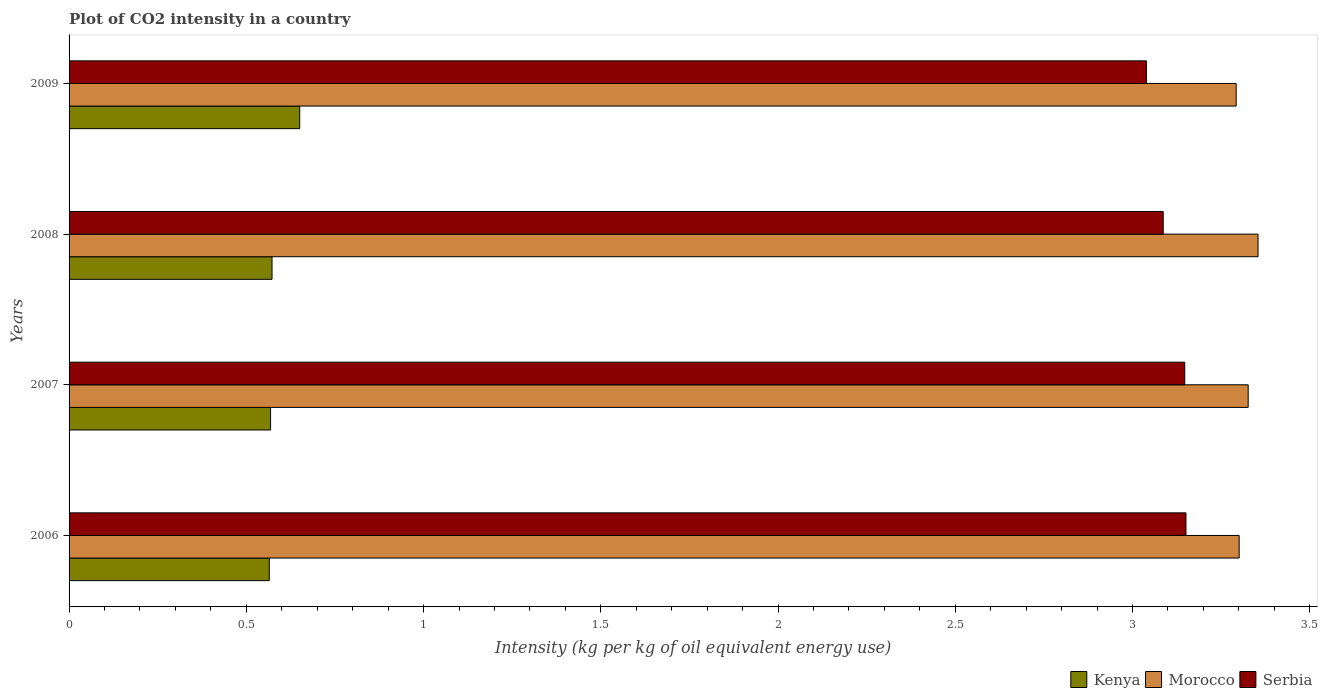How many different coloured bars are there?
Offer a very short reply. 3. Are the number of bars on each tick of the Y-axis equal?
Keep it short and to the point. Yes. What is the label of the 2nd group of bars from the top?
Provide a short and direct response. 2008. What is the CO2 intensity in in Morocco in 2007?
Make the answer very short. 3.33. Across all years, what is the maximum CO2 intensity in in Serbia?
Offer a terse response. 3.15. Across all years, what is the minimum CO2 intensity in in Serbia?
Offer a very short reply. 3.04. In which year was the CO2 intensity in in Morocco maximum?
Give a very brief answer. 2008. What is the total CO2 intensity in in Kenya in the graph?
Give a very brief answer. 2.36. What is the difference between the CO2 intensity in in Morocco in 2006 and that in 2007?
Your answer should be very brief. -0.03. What is the difference between the CO2 intensity in in Kenya in 2006 and the CO2 intensity in in Serbia in 2009?
Keep it short and to the point. -2.47. What is the average CO2 intensity in in Kenya per year?
Keep it short and to the point. 0.59. In the year 2008, what is the difference between the CO2 intensity in in Kenya and CO2 intensity in in Serbia?
Keep it short and to the point. -2.51. In how many years, is the CO2 intensity in in Kenya greater than 1.9 kg?
Provide a short and direct response. 0. What is the ratio of the CO2 intensity in in Morocco in 2007 to that in 2008?
Provide a succinct answer. 0.99. Is the CO2 intensity in in Kenya in 2007 less than that in 2009?
Make the answer very short. Yes. Is the difference between the CO2 intensity in in Kenya in 2006 and 2008 greater than the difference between the CO2 intensity in in Serbia in 2006 and 2008?
Provide a short and direct response. No. What is the difference between the highest and the second highest CO2 intensity in in Morocco?
Provide a succinct answer. 0.03. What is the difference between the highest and the lowest CO2 intensity in in Morocco?
Your response must be concise. 0.06. In how many years, is the CO2 intensity in in Kenya greater than the average CO2 intensity in in Kenya taken over all years?
Your response must be concise. 1. What does the 2nd bar from the top in 2008 represents?
Your response must be concise. Morocco. What does the 2nd bar from the bottom in 2006 represents?
Offer a terse response. Morocco. Is it the case that in every year, the sum of the CO2 intensity in in Serbia and CO2 intensity in in Kenya is greater than the CO2 intensity in in Morocco?
Keep it short and to the point. Yes. How many bars are there?
Provide a succinct answer. 12. Are all the bars in the graph horizontal?
Offer a terse response. Yes. How many years are there in the graph?
Ensure brevity in your answer.  4. Are the values on the major ticks of X-axis written in scientific E-notation?
Provide a succinct answer. No. Does the graph contain any zero values?
Your answer should be compact. No. Does the graph contain grids?
Your response must be concise. No. How are the legend labels stacked?
Your response must be concise. Horizontal. What is the title of the graph?
Your answer should be very brief. Plot of CO2 intensity in a country. Does "Georgia" appear as one of the legend labels in the graph?
Offer a very short reply. No. What is the label or title of the X-axis?
Make the answer very short. Intensity (kg per kg of oil equivalent energy use). What is the Intensity (kg per kg of oil equivalent energy use) of Kenya in 2006?
Provide a succinct answer. 0.56. What is the Intensity (kg per kg of oil equivalent energy use) in Morocco in 2006?
Make the answer very short. 3.3. What is the Intensity (kg per kg of oil equivalent energy use) of Serbia in 2006?
Offer a very short reply. 3.15. What is the Intensity (kg per kg of oil equivalent energy use) of Kenya in 2007?
Make the answer very short. 0.57. What is the Intensity (kg per kg of oil equivalent energy use) in Morocco in 2007?
Provide a short and direct response. 3.33. What is the Intensity (kg per kg of oil equivalent energy use) of Serbia in 2007?
Ensure brevity in your answer.  3.15. What is the Intensity (kg per kg of oil equivalent energy use) of Kenya in 2008?
Your response must be concise. 0.57. What is the Intensity (kg per kg of oil equivalent energy use) of Morocco in 2008?
Give a very brief answer. 3.35. What is the Intensity (kg per kg of oil equivalent energy use) in Serbia in 2008?
Give a very brief answer. 3.09. What is the Intensity (kg per kg of oil equivalent energy use) of Kenya in 2009?
Offer a very short reply. 0.65. What is the Intensity (kg per kg of oil equivalent energy use) of Morocco in 2009?
Keep it short and to the point. 3.29. What is the Intensity (kg per kg of oil equivalent energy use) of Serbia in 2009?
Offer a terse response. 3.04. Across all years, what is the maximum Intensity (kg per kg of oil equivalent energy use) of Kenya?
Ensure brevity in your answer.  0.65. Across all years, what is the maximum Intensity (kg per kg of oil equivalent energy use) in Morocco?
Your answer should be compact. 3.35. Across all years, what is the maximum Intensity (kg per kg of oil equivalent energy use) of Serbia?
Your answer should be compact. 3.15. Across all years, what is the minimum Intensity (kg per kg of oil equivalent energy use) in Kenya?
Offer a very short reply. 0.56. Across all years, what is the minimum Intensity (kg per kg of oil equivalent energy use) of Morocco?
Offer a very short reply. 3.29. Across all years, what is the minimum Intensity (kg per kg of oil equivalent energy use) in Serbia?
Your response must be concise. 3.04. What is the total Intensity (kg per kg of oil equivalent energy use) of Kenya in the graph?
Provide a short and direct response. 2.36. What is the total Intensity (kg per kg of oil equivalent energy use) of Morocco in the graph?
Ensure brevity in your answer.  13.27. What is the total Intensity (kg per kg of oil equivalent energy use) in Serbia in the graph?
Make the answer very short. 12.42. What is the difference between the Intensity (kg per kg of oil equivalent energy use) in Kenya in 2006 and that in 2007?
Make the answer very short. -0. What is the difference between the Intensity (kg per kg of oil equivalent energy use) of Morocco in 2006 and that in 2007?
Your answer should be very brief. -0.03. What is the difference between the Intensity (kg per kg of oil equivalent energy use) in Serbia in 2006 and that in 2007?
Your answer should be compact. 0. What is the difference between the Intensity (kg per kg of oil equivalent energy use) in Kenya in 2006 and that in 2008?
Your answer should be compact. -0.01. What is the difference between the Intensity (kg per kg of oil equivalent energy use) of Morocco in 2006 and that in 2008?
Offer a terse response. -0.05. What is the difference between the Intensity (kg per kg of oil equivalent energy use) in Serbia in 2006 and that in 2008?
Make the answer very short. 0.06. What is the difference between the Intensity (kg per kg of oil equivalent energy use) in Kenya in 2006 and that in 2009?
Keep it short and to the point. -0.09. What is the difference between the Intensity (kg per kg of oil equivalent energy use) of Morocco in 2006 and that in 2009?
Your answer should be compact. 0.01. What is the difference between the Intensity (kg per kg of oil equivalent energy use) of Serbia in 2006 and that in 2009?
Offer a terse response. 0.11. What is the difference between the Intensity (kg per kg of oil equivalent energy use) in Kenya in 2007 and that in 2008?
Ensure brevity in your answer.  -0. What is the difference between the Intensity (kg per kg of oil equivalent energy use) of Morocco in 2007 and that in 2008?
Provide a succinct answer. -0.03. What is the difference between the Intensity (kg per kg of oil equivalent energy use) of Serbia in 2007 and that in 2008?
Offer a terse response. 0.06. What is the difference between the Intensity (kg per kg of oil equivalent energy use) in Kenya in 2007 and that in 2009?
Your answer should be very brief. -0.08. What is the difference between the Intensity (kg per kg of oil equivalent energy use) in Morocco in 2007 and that in 2009?
Offer a terse response. 0.03. What is the difference between the Intensity (kg per kg of oil equivalent energy use) in Serbia in 2007 and that in 2009?
Make the answer very short. 0.11. What is the difference between the Intensity (kg per kg of oil equivalent energy use) of Kenya in 2008 and that in 2009?
Ensure brevity in your answer.  -0.08. What is the difference between the Intensity (kg per kg of oil equivalent energy use) of Morocco in 2008 and that in 2009?
Offer a very short reply. 0.06. What is the difference between the Intensity (kg per kg of oil equivalent energy use) of Serbia in 2008 and that in 2009?
Your response must be concise. 0.05. What is the difference between the Intensity (kg per kg of oil equivalent energy use) in Kenya in 2006 and the Intensity (kg per kg of oil equivalent energy use) in Morocco in 2007?
Ensure brevity in your answer.  -2.76. What is the difference between the Intensity (kg per kg of oil equivalent energy use) in Kenya in 2006 and the Intensity (kg per kg of oil equivalent energy use) in Serbia in 2007?
Ensure brevity in your answer.  -2.58. What is the difference between the Intensity (kg per kg of oil equivalent energy use) in Morocco in 2006 and the Intensity (kg per kg of oil equivalent energy use) in Serbia in 2007?
Provide a succinct answer. 0.15. What is the difference between the Intensity (kg per kg of oil equivalent energy use) of Kenya in 2006 and the Intensity (kg per kg of oil equivalent energy use) of Morocco in 2008?
Make the answer very short. -2.79. What is the difference between the Intensity (kg per kg of oil equivalent energy use) in Kenya in 2006 and the Intensity (kg per kg of oil equivalent energy use) in Serbia in 2008?
Offer a terse response. -2.52. What is the difference between the Intensity (kg per kg of oil equivalent energy use) of Morocco in 2006 and the Intensity (kg per kg of oil equivalent energy use) of Serbia in 2008?
Your answer should be very brief. 0.21. What is the difference between the Intensity (kg per kg of oil equivalent energy use) of Kenya in 2006 and the Intensity (kg per kg of oil equivalent energy use) of Morocco in 2009?
Ensure brevity in your answer.  -2.73. What is the difference between the Intensity (kg per kg of oil equivalent energy use) in Kenya in 2006 and the Intensity (kg per kg of oil equivalent energy use) in Serbia in 2009?
Your response must be concise. -2.47. What is the difference between the Intensity (kg per kg of oil equivalent energy use) of Morocco in 2006 and the Intensity (kg per kg of oil equivalent energy use) of Serbia in 2009?
Provide a short and direct response. 0.26. What is the difference between the Intensity (kg per kg of oil equivalent energy use) of Kenya in 2007 and the Intensity (kg per kg of oil equivalent energy use) of Morocco in 2008?
Provide a short and direct response. -2.79. What is the difference between the Intensity (kg per kg of oil equivalent energy use) in Kenya in 2007 and the Intensity (kg per kg of oil equivalent energy use) in Serbia in 2008?
Your answer should be very brief. -2.52. What is the difference between the Intensity (kg per kg of oil equivalent energy use) in Morocco in 2007 and the Intensity (kg per kg of oil equivalent energy use) in Serbia in 2008?
Make the answer very short. 0.24. What is the difference between the Intensity (kg per kg of oil equivalent energy use) of Kenya in 2007 and the Intensity (kg per kg of oil equivalent energy use) of Morocco in 2009?
Your answer should be compact. -2.72. What is the difference between the Intensity (kg per kg of oil equivalent energy use) of Kenya in 2007 and the Intensity (kg per kg of oil equivalent energy use) of Serbia in 2009?
Give a very brief answer. -2.47. What is the difference between the Intensity (kg per kg of oil equivalent energy use) in Morocco in 2007 and the Intensity (kg per kg of oil equivalent energy use) in Serbia in 2009?
Keep it short and to the point. 0.29. What is the difference between the Intensity (kg per kg of oil equivalent energy use) in Kenya in 2008 and the Intensity (kg per kg of oil equivalent energy use) in Morocco in 2009?
Make the answer very short. -2.72. What is the difference between the Intensity (kg per kg of oil equivalent energy use) in Kenya in 2008 and the Intensity (kg per kg of oil equivalent energy use) in Serbia in 2009?
Ensure brevity in your answer.  -2.47. What is the difference between the Intensity (kg per kg of oil equivalent energy use) in Morocco in 2008 and the Intensity (kg per kg of oil equivalent energy use) in Serbia in 2009?
Your response must be concise. 0.31. What is the average Intensity (kg per kg of oil equivalent energy use) in Kenya per year?
Ensure brevity in your answer.  0.59. What is the average Intensity (kg per kg of oil equivalent energy use) in Morocco per year?
Give a very brief answer. 3.32. What is the average Intensity (kg per kg of oil equivalent energy use) in Serbia per year?
Give a very brief answer. 3.11. In the year 2006, what is the difference between the Intensity (kg per kg of oil equivalent energy use) of Kenya and Intensity (kg per kg of oil equivalent energy use) of Morocco?
Provide a succinct answer. -2.74. In the year 2006, what is the difference between the Intensity (kg per kg of oil equivalent energy use) in Kenya and Intensity (kg per kg of oil equivalent energy use) in Serbia?
Keep it short and to the point. -2.59. In the year 2006, what is the difference between the Intensity (kg per kg of oil equivalent energy use) of Morocco and Intensity (kg per kg of oil equivalent energy use) of Serbia?
Make the answer very short. 0.15. In the year 2007, what is the difference between the Intensity (kg per kg of oil equivalent energy use) in Kenya and Intensity (kg per kg of oil equivalent energy use) in Morocco?
Provide a succinct answer. -2.76. In the year 2007, what is the difference between the Intensity (kg per kg of oil equivalent energy use) in Kenya and Intensity (kg per kg of oil equivalent energy use) in Serbia?
Make the answer very short. -2.58. In the year 2007, what is the difference between the Intensity (kg per kg of oil equivalent energy use) of Morocco and Intensity (kg per kg of oil equivalent energy use) of Serbia?
Give a very brief answer. 0.18. In the year 2008, what is the difference between the Intensity (kg per kg of oil equivalent energy use) of Kenya and Intensity (kg per kg of oil equivalent energy use) of Morocco?
Give a very brief answer. -2.78. In the year 2008, what is the difference between the Intensity (kg per kg of oil equivalent energy use) in Kenya and Intensity (kg per kg of oil equivalent energy use) in Serbia?
Your answer should be very brief. -2.51. In the year 2008, what is the difference between the Intensity (kg per kg of oil equivalent energy use) in Morocco and Intensity (kg per kg of oil equivalent energy use) in Serbia?
Give a very brief answer. 0.27. In the year 2009, what is the difference between the Intensity (kg per kg of oil equivalent energy use) in Kenya and Intensity (kg per kg of oil equivalent energy use) in Morocco?
Provide a succinct answer. -2.64. In the year 2009, what is the difference between the Intensity (kg per kg of oil equivalent energy use) of Kenya and Intensity (kg per kg of oil equivalent energy use) of Serbia?
Make the answer very short. -2.39. In the year 2009, what is the difference between the Intensity (kg per kg of oil equivalent energy use) in Morocco and Intensity (kg per kg of oil equivalent energy use) in Serbia?
Give a very brief answer. 0.25. What is the ratio of the Intensity (kg per kg of oil equivalent energy use) of Kenya in 2006 to that in 2007?
Ensure brevity in your answer.  0.99. What is the ratio of the Intensity (kg per kg of oil equivalent energy use) in Kenya in 2006 to that in 2008?
Your response must be concise. 0.99. What is the ratio of the Intensity (kg per kg of oil equivalent energy use) of Morocco in 2006 to that in 2008?
Your response must be concise. 0.98. What is the ratio of the Intensity (kg per kg of oil equivalent energy use) in Serbia in 2006 to that in 2008?
Give a very brief answer. 1.02. What is the ratio of the Intensity (kg per kg of oil equivalent energy use) in Kenya in 2006 to that in 2009?
Provide a succinct answer. 0.87. What is the ratio of the Intensity (kg per kg of oil equivalent energy use) in Morocco in 2006 to that in 2009?
Provide a short and direct response. 1. What is the ratio of the Intensity (kg per kg of oil equivalent energy use) in Serbia in 2006 to that in 2009?
Your response must be concise. 1.04. What is the ratio of the Intensity (kg per kg of oil equivalent energy use) in Kenya in 2007 to that in 2008?
Your answer should be compact. 0.99. What is the ratio of the Intensity (kg per kg of oil equivalent energy use) of Morocco in 2007 to that in 2008?
Your answer should be compact. 0.99. What is the ratio of the Intensity (kg per kg of oil equivalent energy use) of Serbia in 2007 to that in 2008?
Ensure brevity in your answer.  1.02. What is the ratio of the Intensity (kg per kg of oil equivalent energy use) in Kenya in 2007 to that in 2009?
Your answer should be compact. 0.87. What is the ratio of the Intensity (kg per kg of oil equivalent energy use) in Morocco in 2007 to that in 2009?
Your answer should be compact. 1.01. What is the ratio of the Intensity (kg per kg of oil equivalent energy use) in Serbia in 2007 to that in 2009?
Your answer should be very brief. 1.04. What is the ratio of the Intensity (kg per kg of oil equivalent energy use) of Morocco in 2008 to that in 2009?
Make the answer very short. 1.02. What is the ratio of the Intensity (kg per kg of oil equivalent energy use) of Serbia in 2008 to that in 2009?
Keep it short and to the point. 1.02. What is the difference between the highest and the second highest Intensity (kg per kg of oil equivalent energy use) of Kenya?
Provide a succinct answer. 0.08. What is the difference between the highest and the second highest Intensity (kg per kg of oil equivalent energy use) in Morocco?
Ensure brevity in your answer.  0.03. What is the difference between the highest and the second highest Intensity (kg per kg of oil equivalent energy use) in Serbia?
Provide a succinct answer. 0. What is the difference between the highest and the lowest Intensity (kg per kg of oil equivalent energy use) of Kenya?
Your answer should be compact. 0.09. What is the difference between the highest and the lowest Intensity (kg per kg of oil equivalent energy use) in Morocco?
Provide a succinct answer. 0.06. What is the difference between the highest and the lowest Intensity (kg per kg of oil equivalent energy use) of Serbia?
Ensure brevity in your answer.  0.11. 